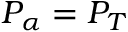Convert formula to latex. <formula><loc_0><loc_0><loc_500><loc_500>P _ { \alpha } = P _ { T }</formula> 